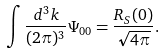Convert formula to latex. <formula><loc_0><loc_0><loc_500><loc_500>\int \frac { d ^ { 3 } { k } } { ( 2 \pi ) ^ { 3 } } \Psi _ { 0 0 } = \frac { R _ { S } ( 0 ) } { \sqrt { 4 \pi } } .</formula> 